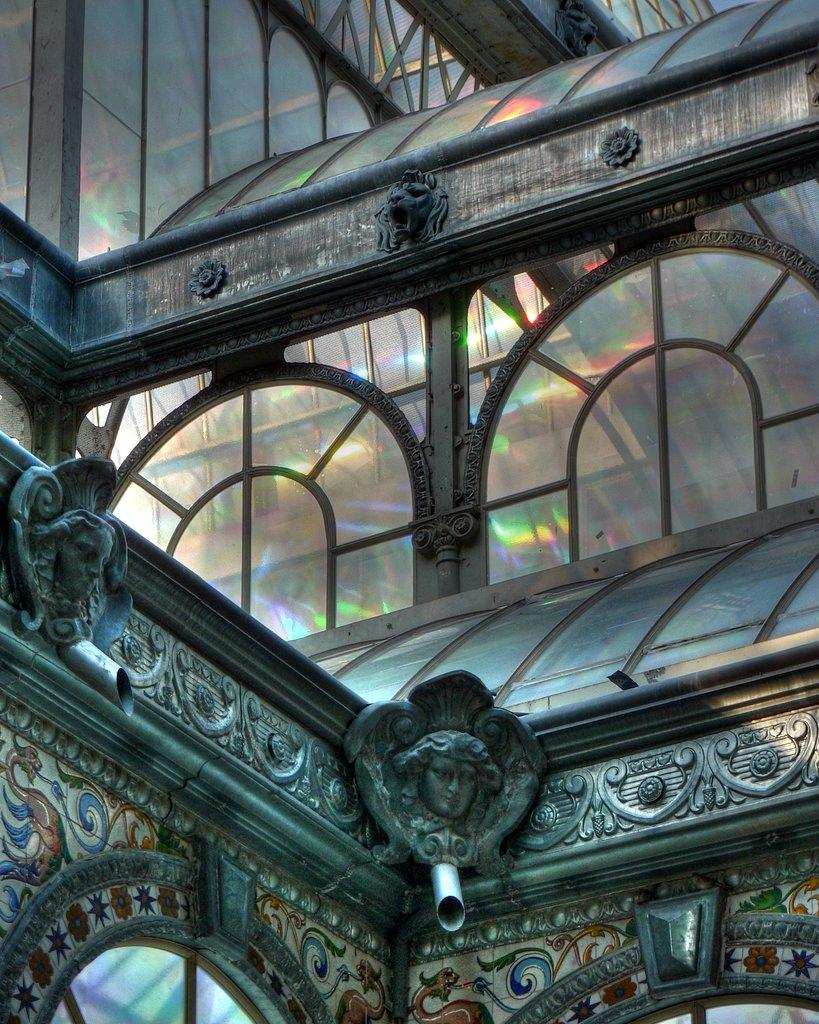What type of building is visible in the image? There is a glass building in the image. What other objects can be seen in the image? There are pipes, sculptures, and carvings in the image. What type of quill is being used by the cattle in the image? There are no cattle or quills present in the image. How does the anger of the sculptures manifest in the image? There are no emotions or expressions associated with the sculptures in the image. 